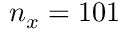<formula> <loc_0><loc_0><loc_500><loc_500>n _ { x } = 1 0 1</formula> 